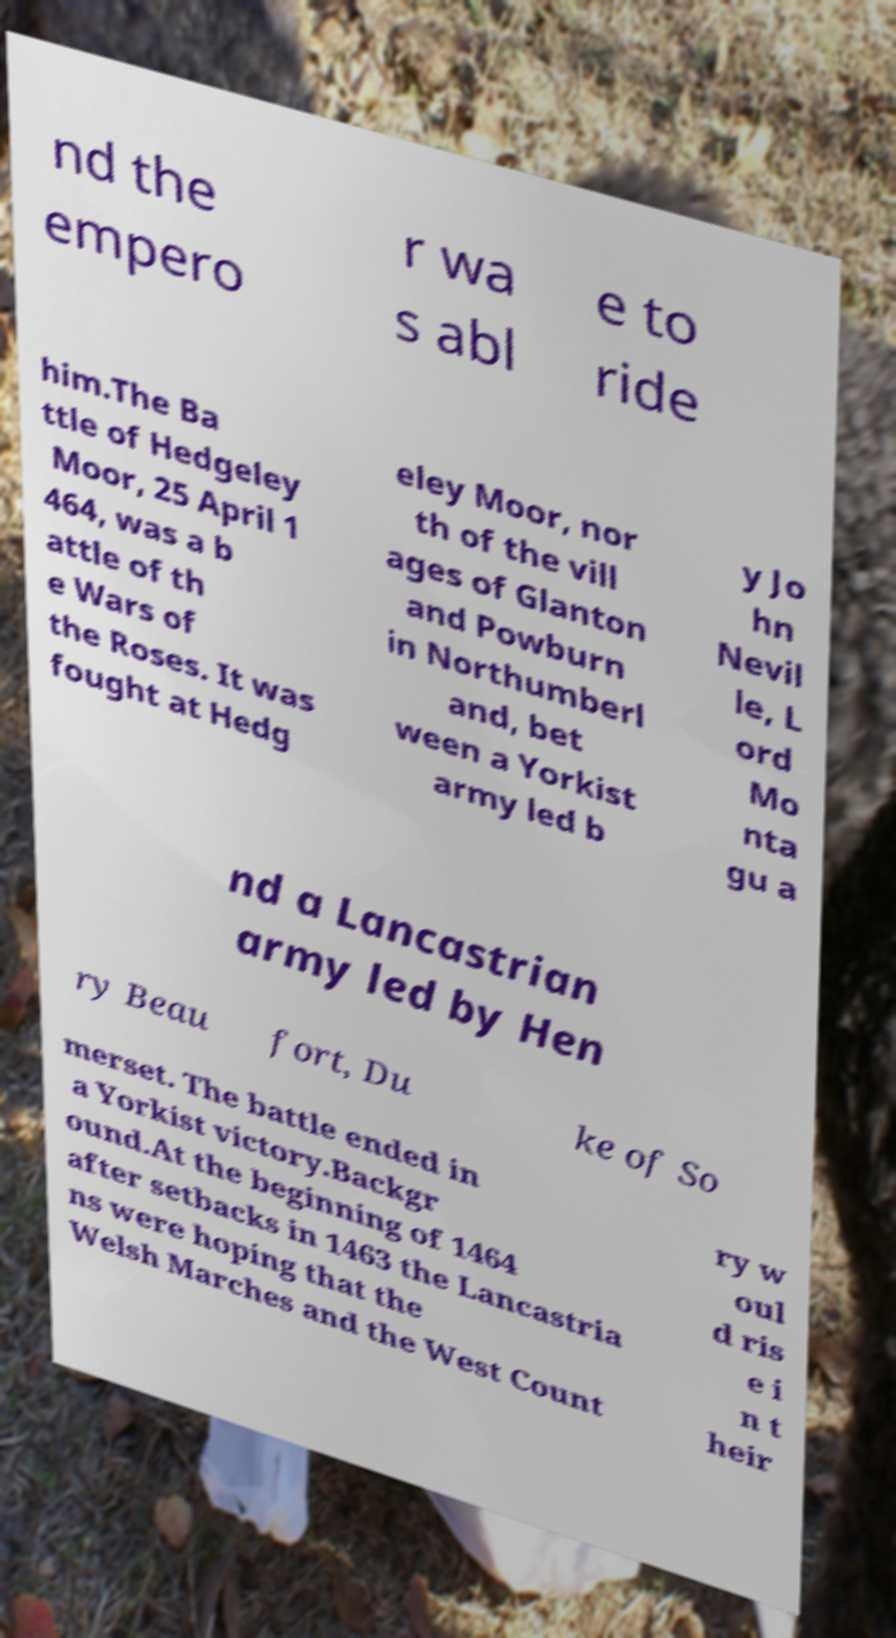Could you assist in decoding the text presented in this image and type it out clearly? nd the empero r wa s abl e to ride him.The Ba ttle of Hedgeley Moor, 25 April 1 464, was a b attle of th e Wars of the Roses. It was fought at Hedg eley Moor, nor th of the vill ages of Glanton and Powburn in Northumberl and, bet ween a Yorkist army led b y Jo hn Nevil le, L ord Mo nta gu a nd a Lancastrian army led by Hen ry Beau fort, Du ke of So merset. The battle ended in a Yorkist victory.Backgr ound.At the beginning of 1464 after setbacks in 1463 the Lancastria ns were hoping that the Welsh Marches and the West Count ry w oul d ris e i n t heir 